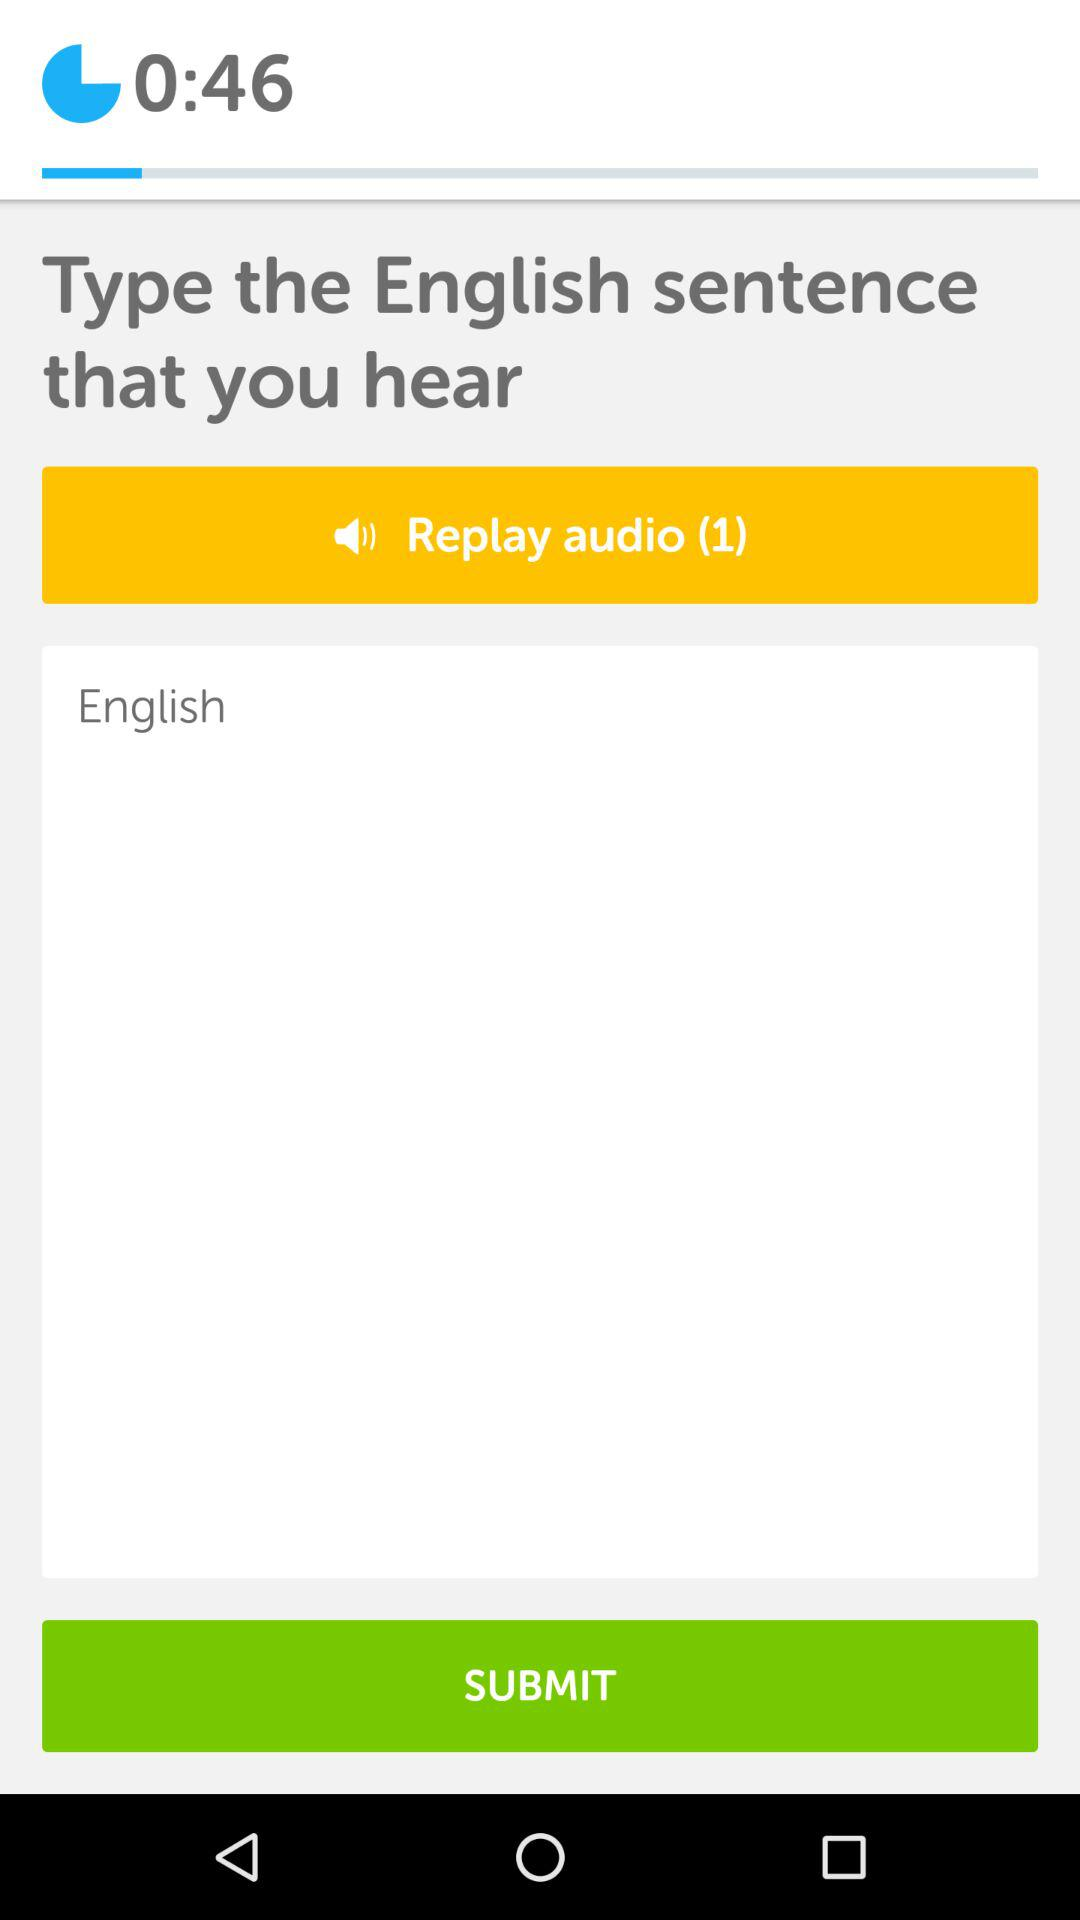How many times can you replay the audio? You can replay the audio once. 